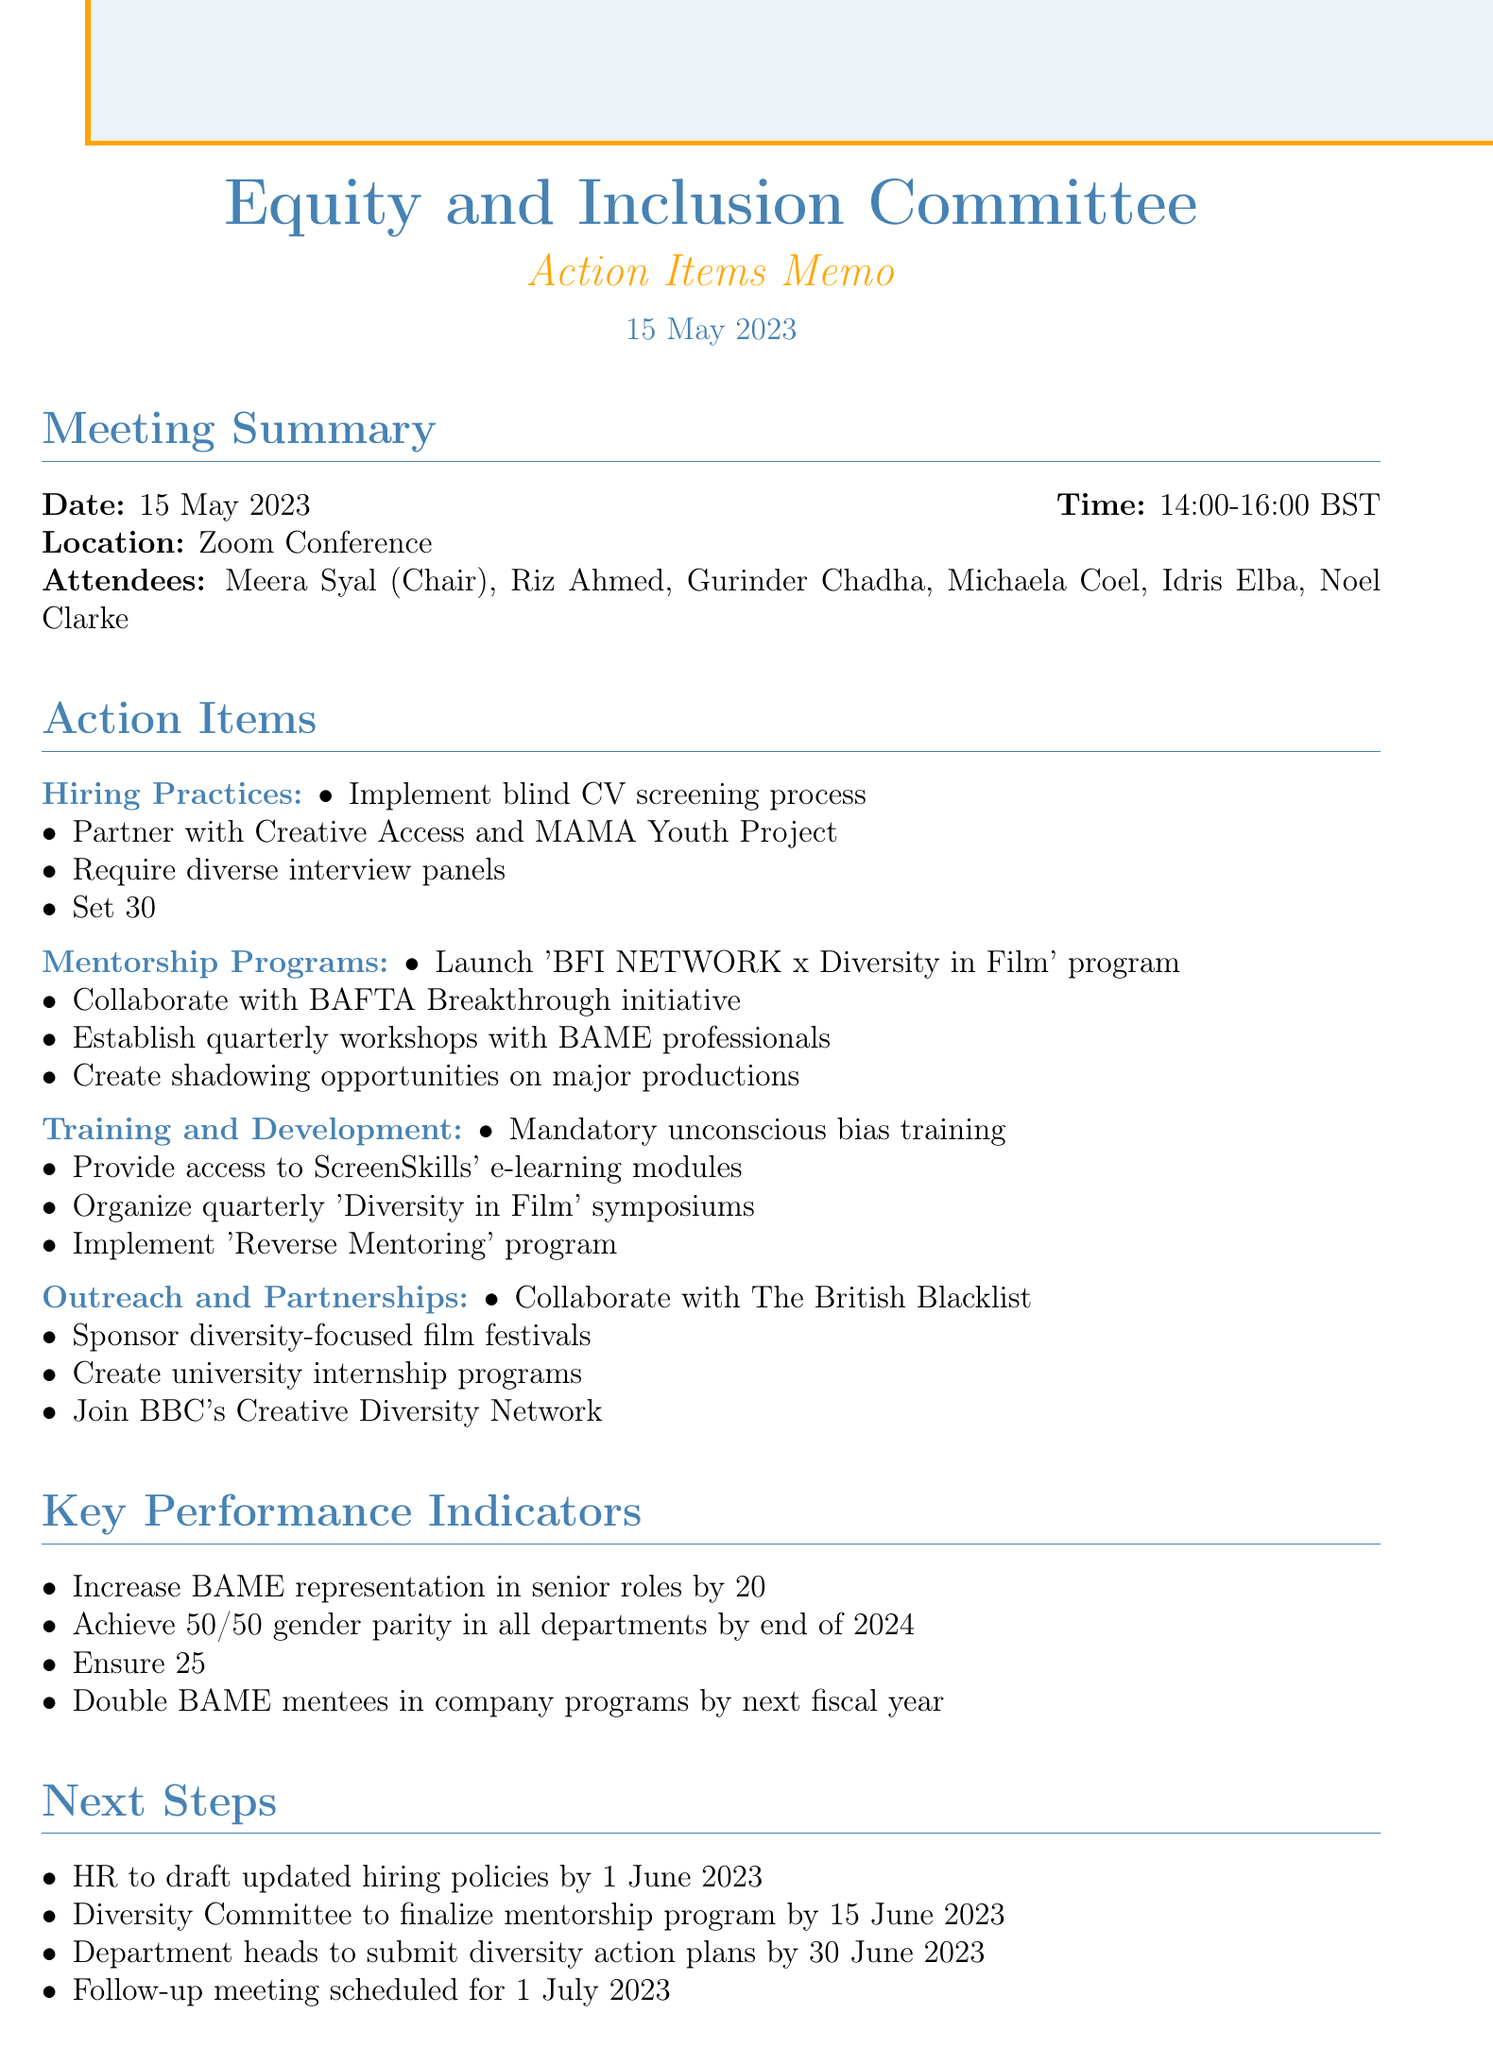what is the date of the meeting? The date of the meeting is explicitly mentioned in the document, which is 15 May 2023.
Answer: 15 May 2023 who is the chair of the committee? The chair of the committee is named in the list of attendees, which is Meera Syal.
Answer: Meera Syal what is the target for BAME representation in new hires? The document specifies a target for BAME representation in new hires, which is 30%.
Answer: 30% how many key performance indicators are listed? The number of key performance indicators is determined by counting the items in the respective section, which totals four.
Answer: four by when does HR need to draft updated hiring policies? The specific deadline for HR to draft the updated hiring policies is stated in the next steps section, which is 1 June 2023.
Answer: 1 June 2023 which mentorship program is being launched? The specific mentorship program launch is noted as 'BFI NETWORK x Diversity in Film'.
Answer: 'BFI NETWORK x Diversity in Film' what percentage increase in BAME representation is aimed for in senior roles? The document outlines the goal for increasing BAME representation in senior roles by 20%.
Answer: 20% when is the follow-up meeting scheduled? The scheduled time for the follow-up meeting is mentioned in the next steps section, which is 1 July 2023.
Answer: 1 July 2023 what organization is mentioned for collaboration on talent sourcing? The organization designated for collaboration on talent sourcing is The British Blacklist.
Answer: The British Blacklist 